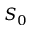Convert formula to latex. <formula><loc_0><loc_0><loc_500><loc_500>S _ { 0 }</formula> 